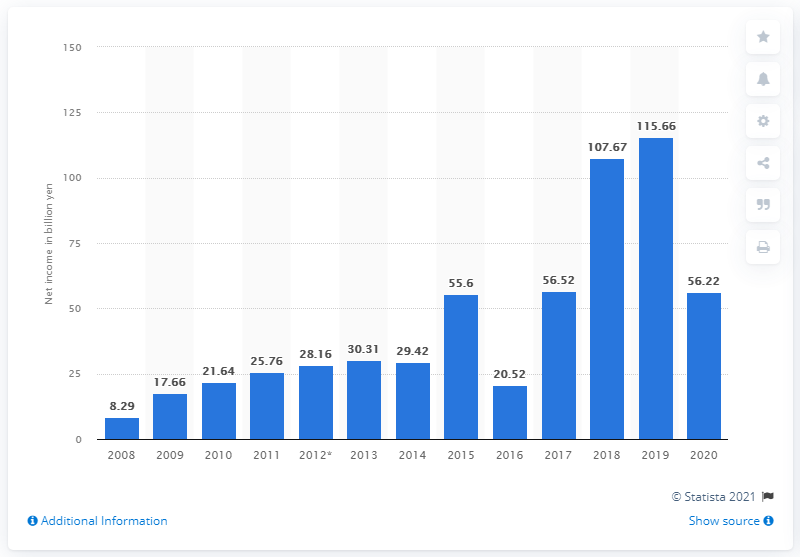Specify some key components in this picture. Nexon's net income in the previous year was 115.66 million. Nexon's net income in 2020 was 56.22 billion. 